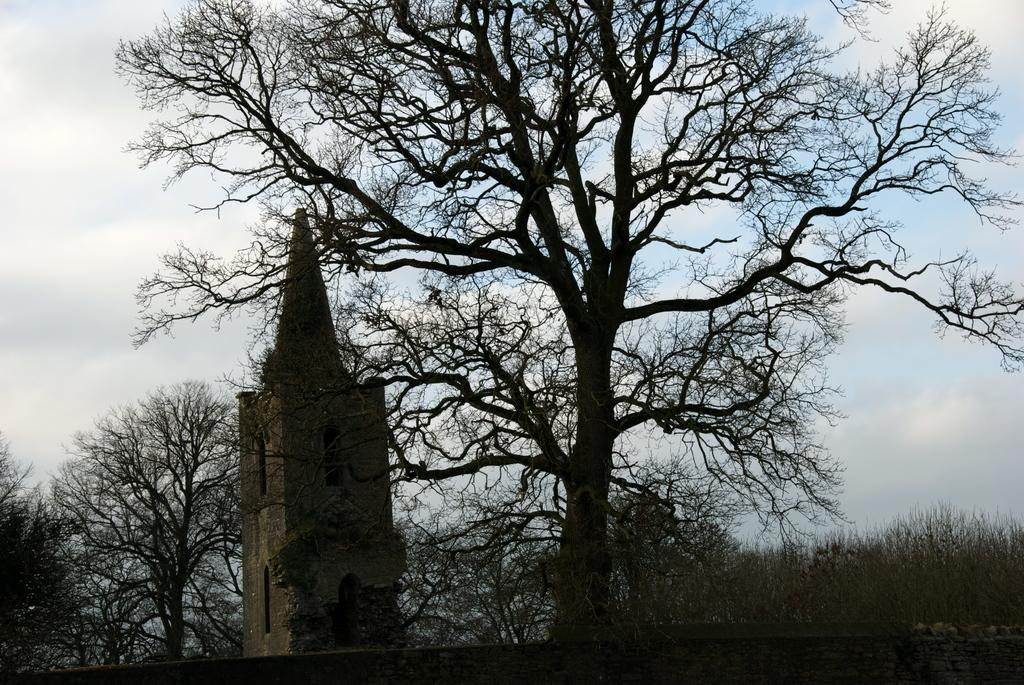What is the main structure in the picture? There is a tower in the picture. What type of vegetation can be seen in the picture? There are trees in the picture. What is visible in the background of the picture? The sky is visible in the background of the picture. What holiday is being celebrated in the picture? There is no indication of a holiday being celebrated in the picture. What position does the tower hold in relation to the trees? The position of the tower in relation to the trees cannot be determined from the image alone, as it only shows the tower and trees without any context or reference points. 